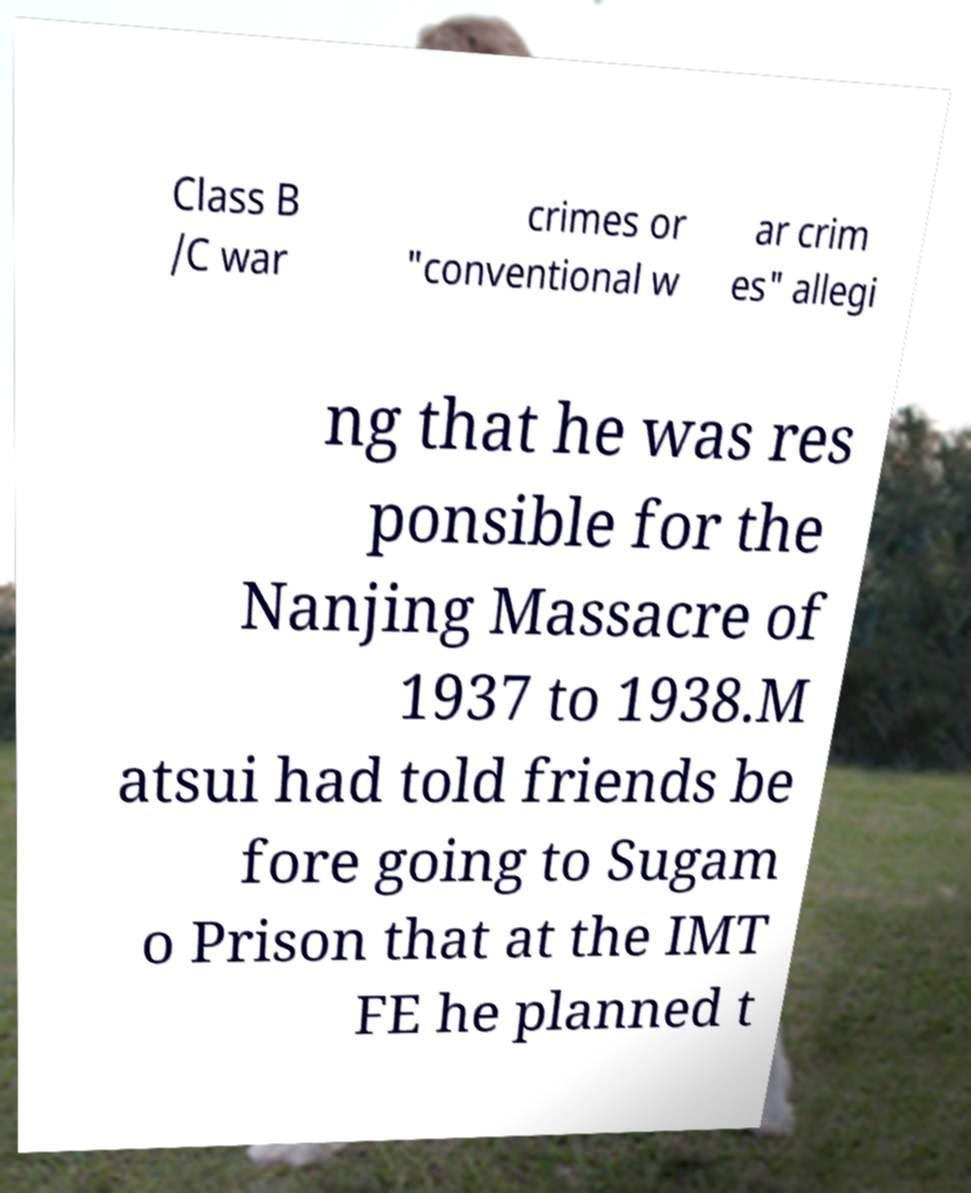Please read and relay the text visible in this image. What does it say? Class B /C war crimes or "conventional w ar crim es" allegi ng that he was res ponsible for the Nanjing Massacre of 1937 to 1938.M atsui had told friends be fore going to Sugam o Prison that at the IMT FE he planned t 